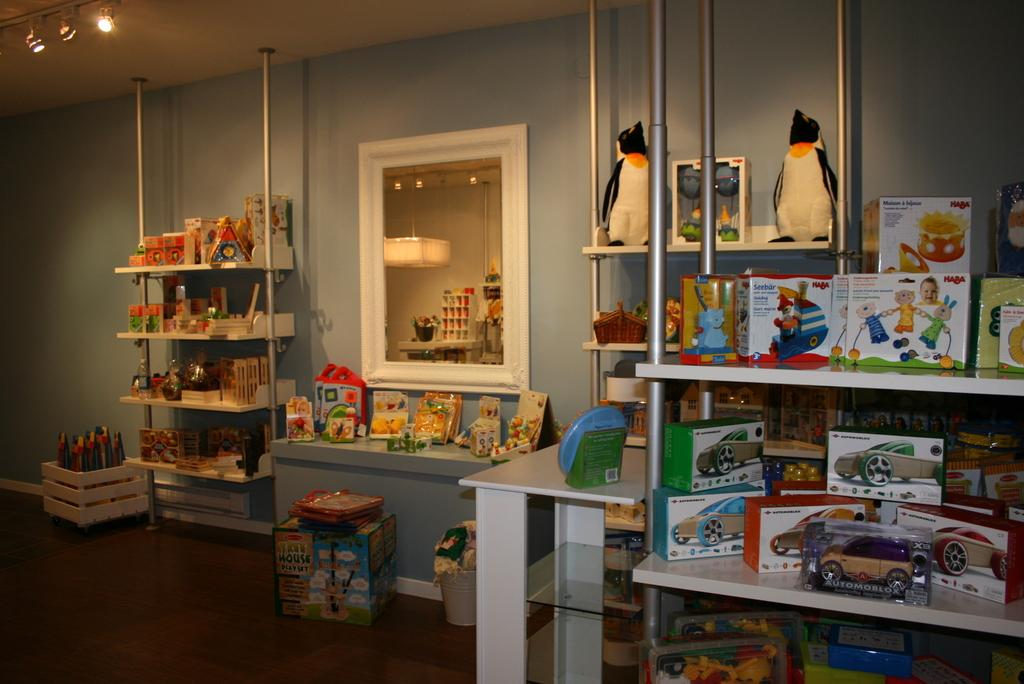Provide a one-sentence caption for the provided image. A big box containing a "Tree House Play Set" sits on the floor in front of a bench. 